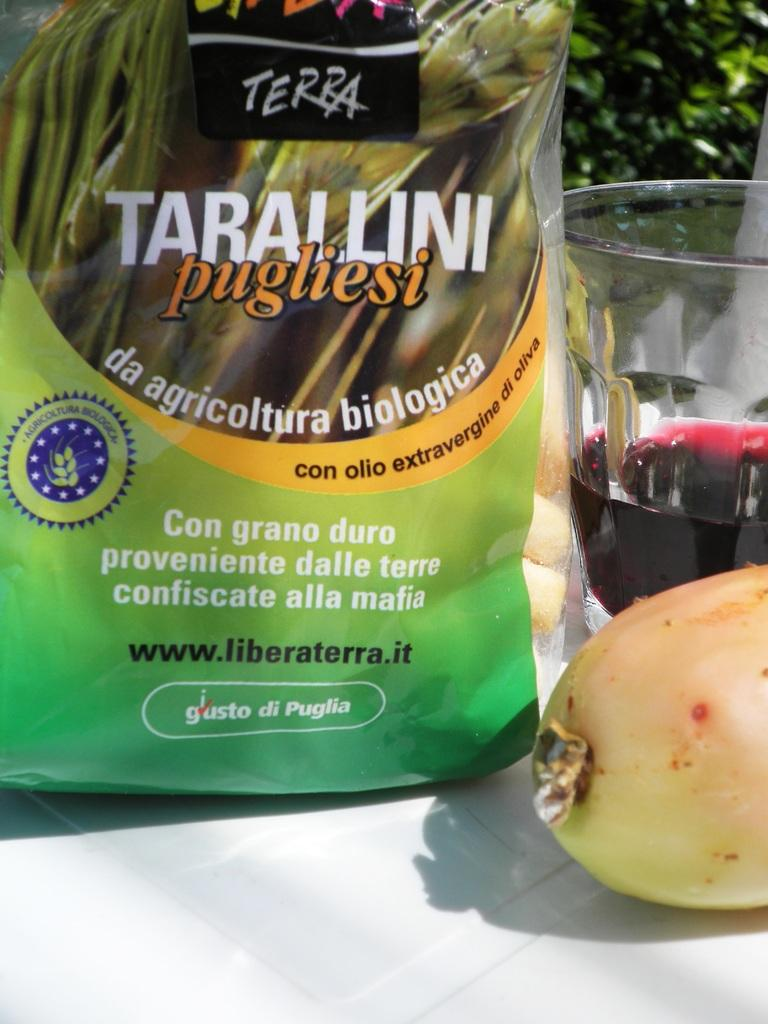<image>
Render a clear and concise summary of the photo. A bag of food with the name Tarallini pugliesi written on it. 